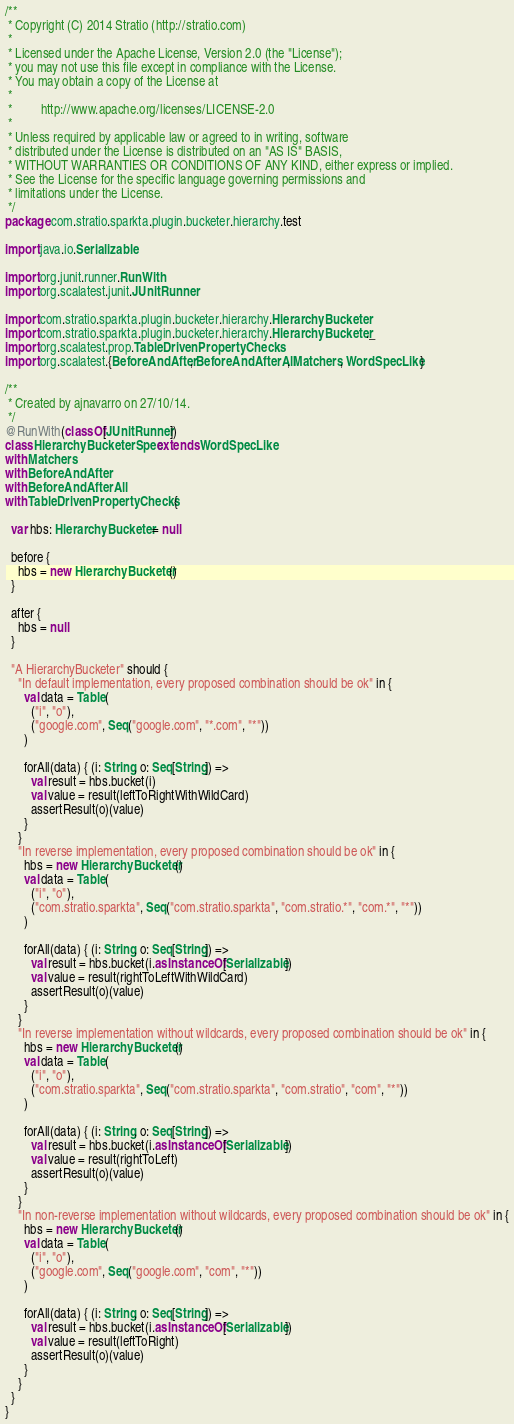<code> <loc_0><loc_0><loc_500><loc_500><_Scala_>/**
 * Copyright (C) 2014 Stratio (http://stratio.com)
 *
 * Licensed under the Apache License, Version 2.0 (the "License");
 * you may not use this file except in compliance with the License.
 * You may obtain a copy of the License at
 *
 *         http://www.apache.org/licenses/LICENSE-2.0
 *
 * Unless required by applicable law or agreed to in writing, software
 * distributed under the License is distributed on an "AS IS" BASIS,
 * WITHOUT WARRANTIES OR CONDITIONS OF ANY KIND, either express or implied.
 * See the License for the specific language governing permissions and
 * limitations under the License.
 */
package com.stratio.sparkta.plugin.bucketer.hierarchy.test

import java.io.Serializable

import org.junit.runner.RunWith
import org.scalatest.junit.JUnitRunner

import com.stratio.sparkta.plugin.bucketer.hierarchy.HierarchyBucketer
import com.stratio.sparkta.plugin.bucketer.hierarchy.HierarchyBucketer._
import org.scalatest.prop.TableDrivenPropertyChecks
import org.scalatest.{BeforeAndAfter, BeforeAndAfterAll, Matchers, WordSpecLike}

/**
 * Created by ajnavarro on 27/10/14.
 */
@RunWith(classOf[JUnitRunner])
class HierarchyBucketerSpec extends WordSpecLike
with Matchers
with BeforeAndAfter
with BeforeAndAfterAll
with TableDrivenPropertyChecks {

  var hbs: HierarchyBucketer = null

  before {
    hbs = new HierarchyBucketer()
  }

  after {
    hbs = null
  }

  "A HierarchyBucketer" should {
    "In default implementation, every proposed combination should be ok" in {
      val data = Table(
        ("i", "o"),
        ("google.com", Seq("google.com", "*.com", "*"))
      )

      forAll(data) { (i: String, o: Seq[String]) =>
        val result = hbs.bucket(i)
        val value = result(leftToRightWithWildCard)
        assertResult(o)(value)
      }
    }
    "In reverse implementation, every proposed combination should be ok" in {
      hbs = new HierarchyBucketer()
      val data = Table(
        ("i", "o"),
        ("com.stratio.sparkta", Seq("com.stratio.sparkta", "com.stratio.*", "com.*", "*"))
      )

      forAll(data) { (i: String, o: Seq[String]) =>
        val result = hbs.bucket(i.asInstanceOf[Serializable])
        val value = result(rightToLeftWithWildCard)
        assertResult(o)(value)
      }
    }
    "In reverse implementation without wildcards, every proposed combination should be ok" in {
      hbs = new HierarchyBucketer()
      val data = Table(
        ("i", "o"),
        ("com.stratio.sparkta", Seq("com.stratio.sparkta", "com.stratio", "com", "*"))
      )

      forAll(data) { (i: String, o: Seq[String]) =>
        val result = hbs.bucket(i.asInstanceOf[Serializable])
        val value = result(rightToLeft)
        assertResult(o)(value)
      }
    }
    "In non-reverse implementation without wildcards, every proposed combination should be ok" in {
      hbs = new HierarchyBucketer()
      val data = Table(
        ("i", "o"),
        ("google.com", Seq("google.com", "com", "*"))
      )

      forAll(data) { (i: String, o: Seq[String]) =>
        val result = hbs.bucket(i.asInstanceOf[Serializable])
        val value = result(leftToRight)
        assertResult(o)(value)
      }
    }
  }
}
</code> 